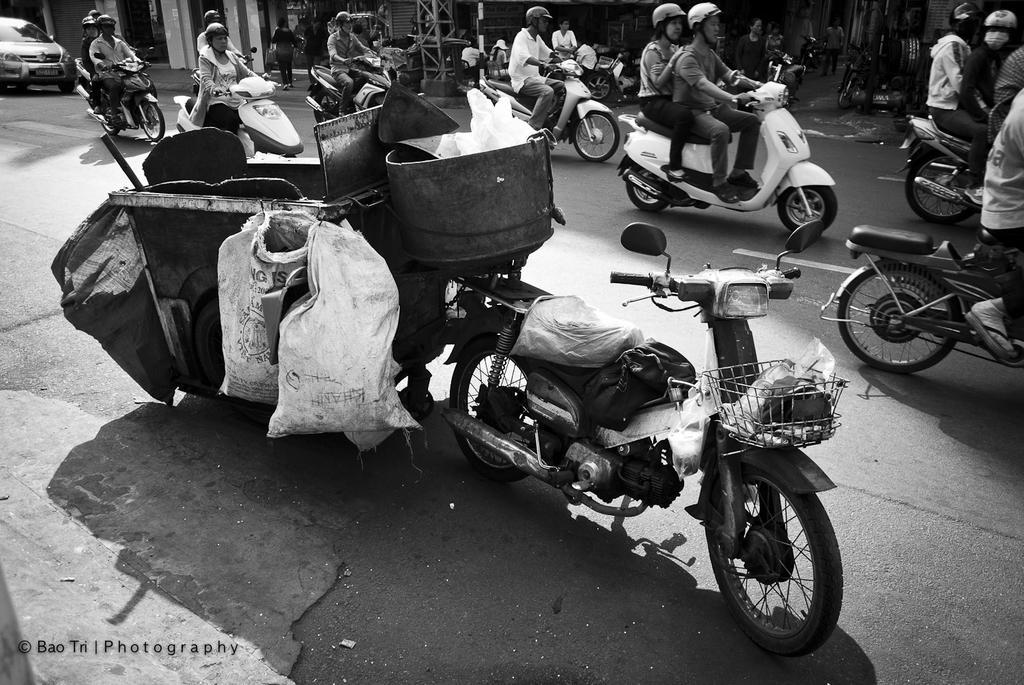Can you describe this image briefly? In the foreground of the picture I can see a motorcycle on the road and there is a garbage container attached to the motorcycle. In the background, I can see a few persons riding a motorcycle on the road. There is a car on the road on the top left side. In the background, I can see a few persons walking on the side of the road. 